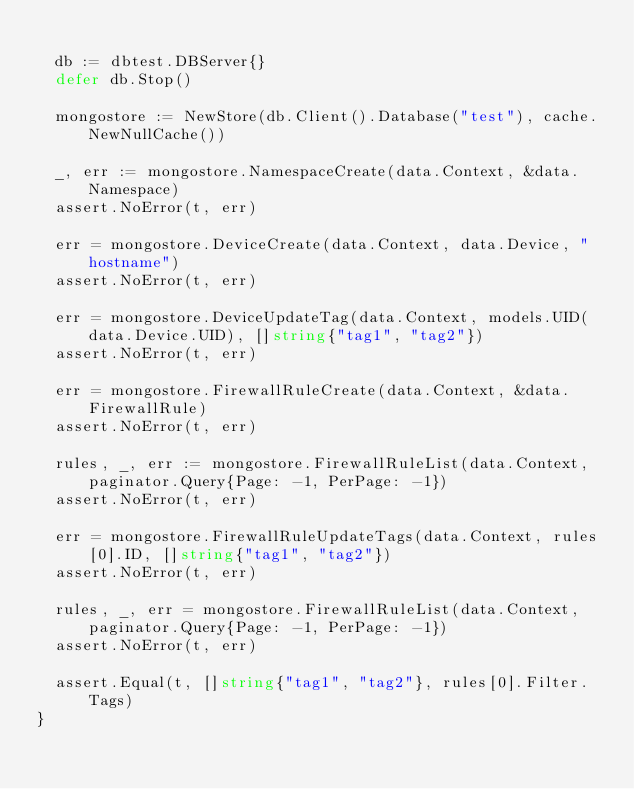Convert code to text. <code><loc_0><loc_0><loc_500><loc_500><_Go_>
	db := dbtest.DBServer{}
	defer db.Stop()

	mongostore := NewStore(db.Client().Database("test"), cache.NewNullCache())

	_, err := mongostore.NamespaceCreate(data.Context, &data.Namespace)
	assert.NoError(t, err)

	err = mongostore.DeviceCreate(data.Context, data.Device, "hostname")
	assert.NoError(t, err)

	err = mongostore.DeviceUpdateTag(data.Context, models.UID(data.Device.UID), []string{"tag1", "tag2"})
	assert.NoError(t, err)

	err = mongostore.FirewallRuleCreate(data.Context, &data.FirewallRule)
	assert.NoError(t, err)

	rules, _, err := mongostore.FirewallRuleList(data.Context, paginator.Query{Page: -1, PerPage: -1})
	assert.NoError(t, err)

	err = mongostore.FirewallRuleUpdateTags(data.Context, rules[0].ID, []string{"tag1", "tag2"})
	assert.NoError(t, err)

	rules, _, err = mongostore.FirewallRuleList(data.Context, paginator.Query{Page: -1, PerPage: -1})
	assert.NoError(t, err)

	assert.Equal(t, []string{"tag1", "tag2"}, rules[0].Filter.Tags)
}
</code> 